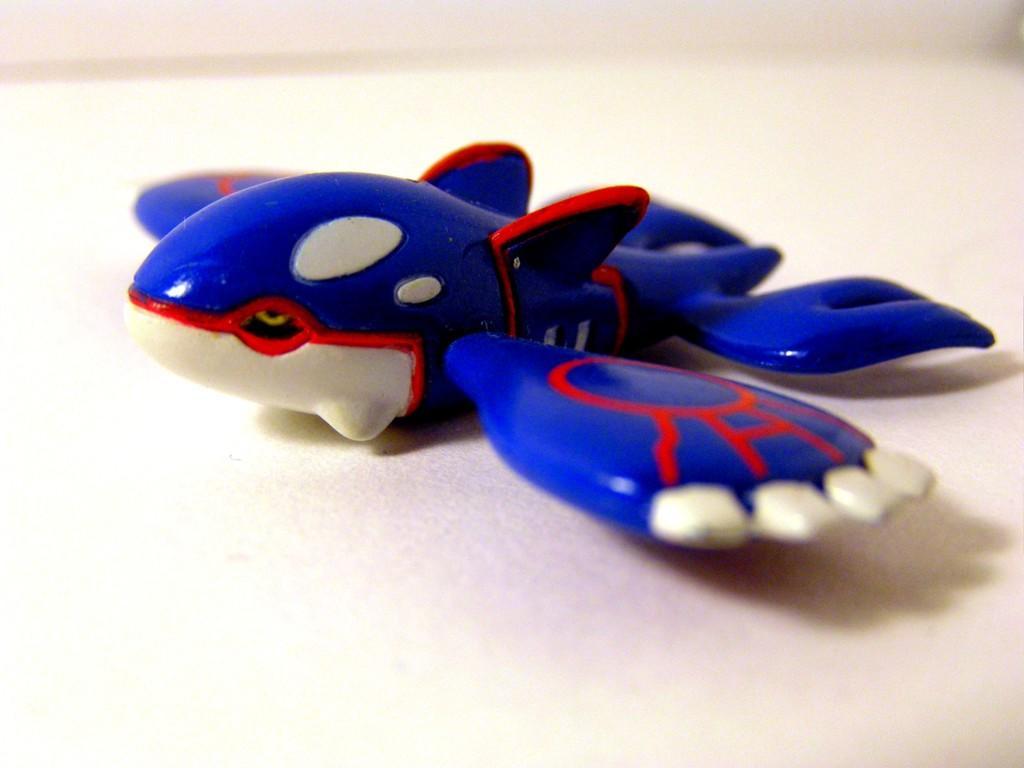Please provide a concise description of this image. In this image we can see an object placed on the ground. 